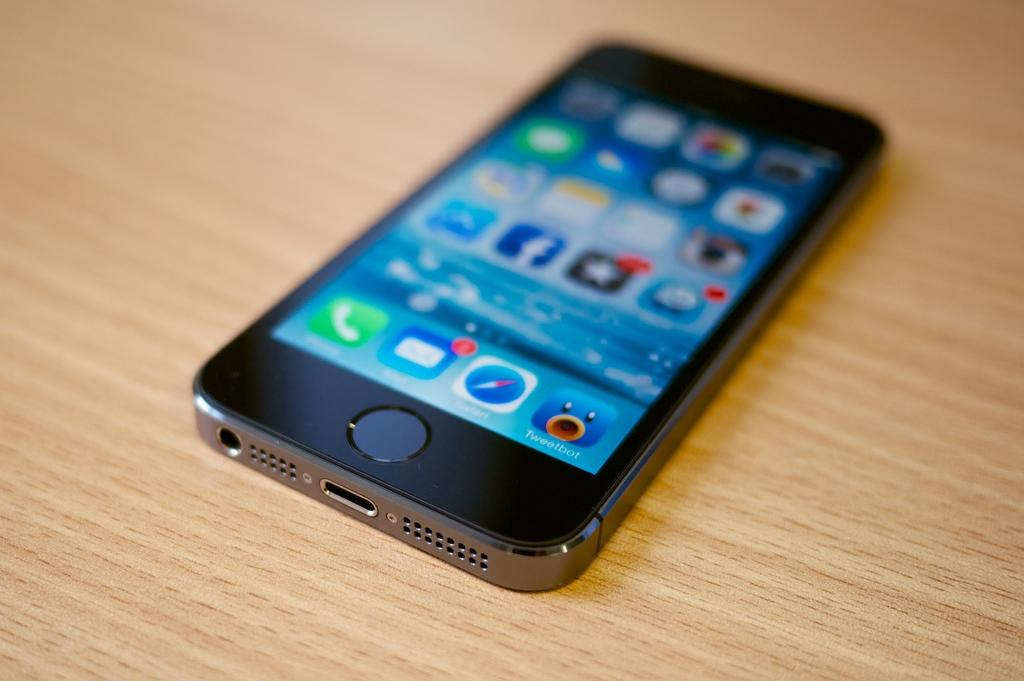<image>
Create a compact narrative representing the image presented. An iPhone is on a wooden table and shows an app called Tweetbot. 